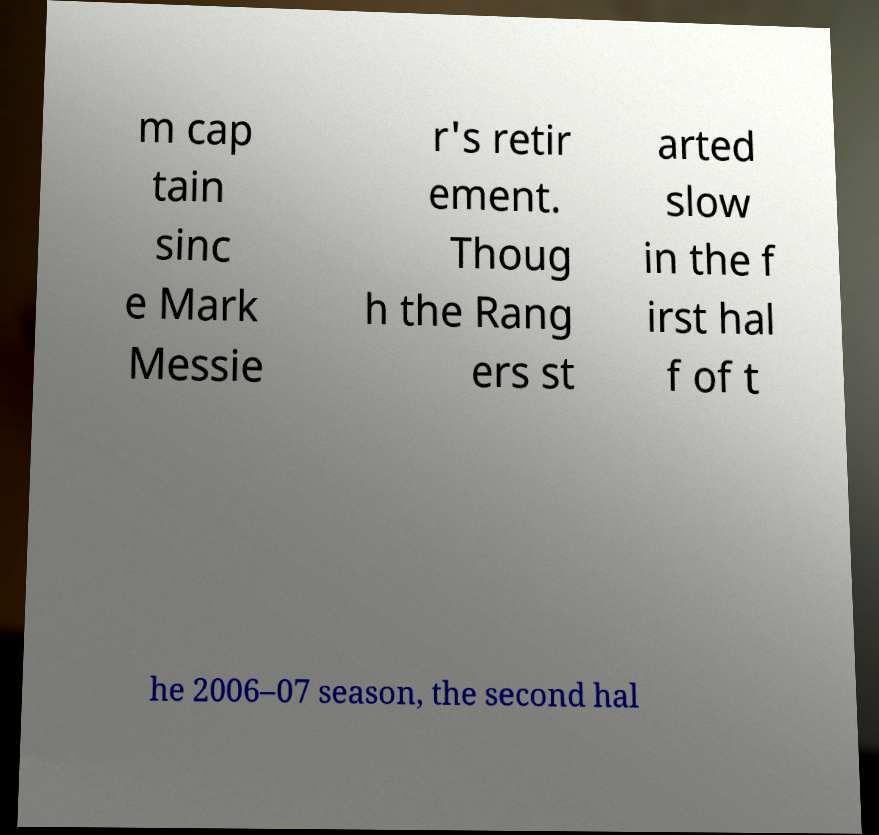Could you assist in decoding the text presented in this image and type it out clearly? m cap tain sinc e Mark Messie r's retir ement. Thoug h the Rang ers st arted slow in the f irst hal f of t he 2006–07 season, the second hal 